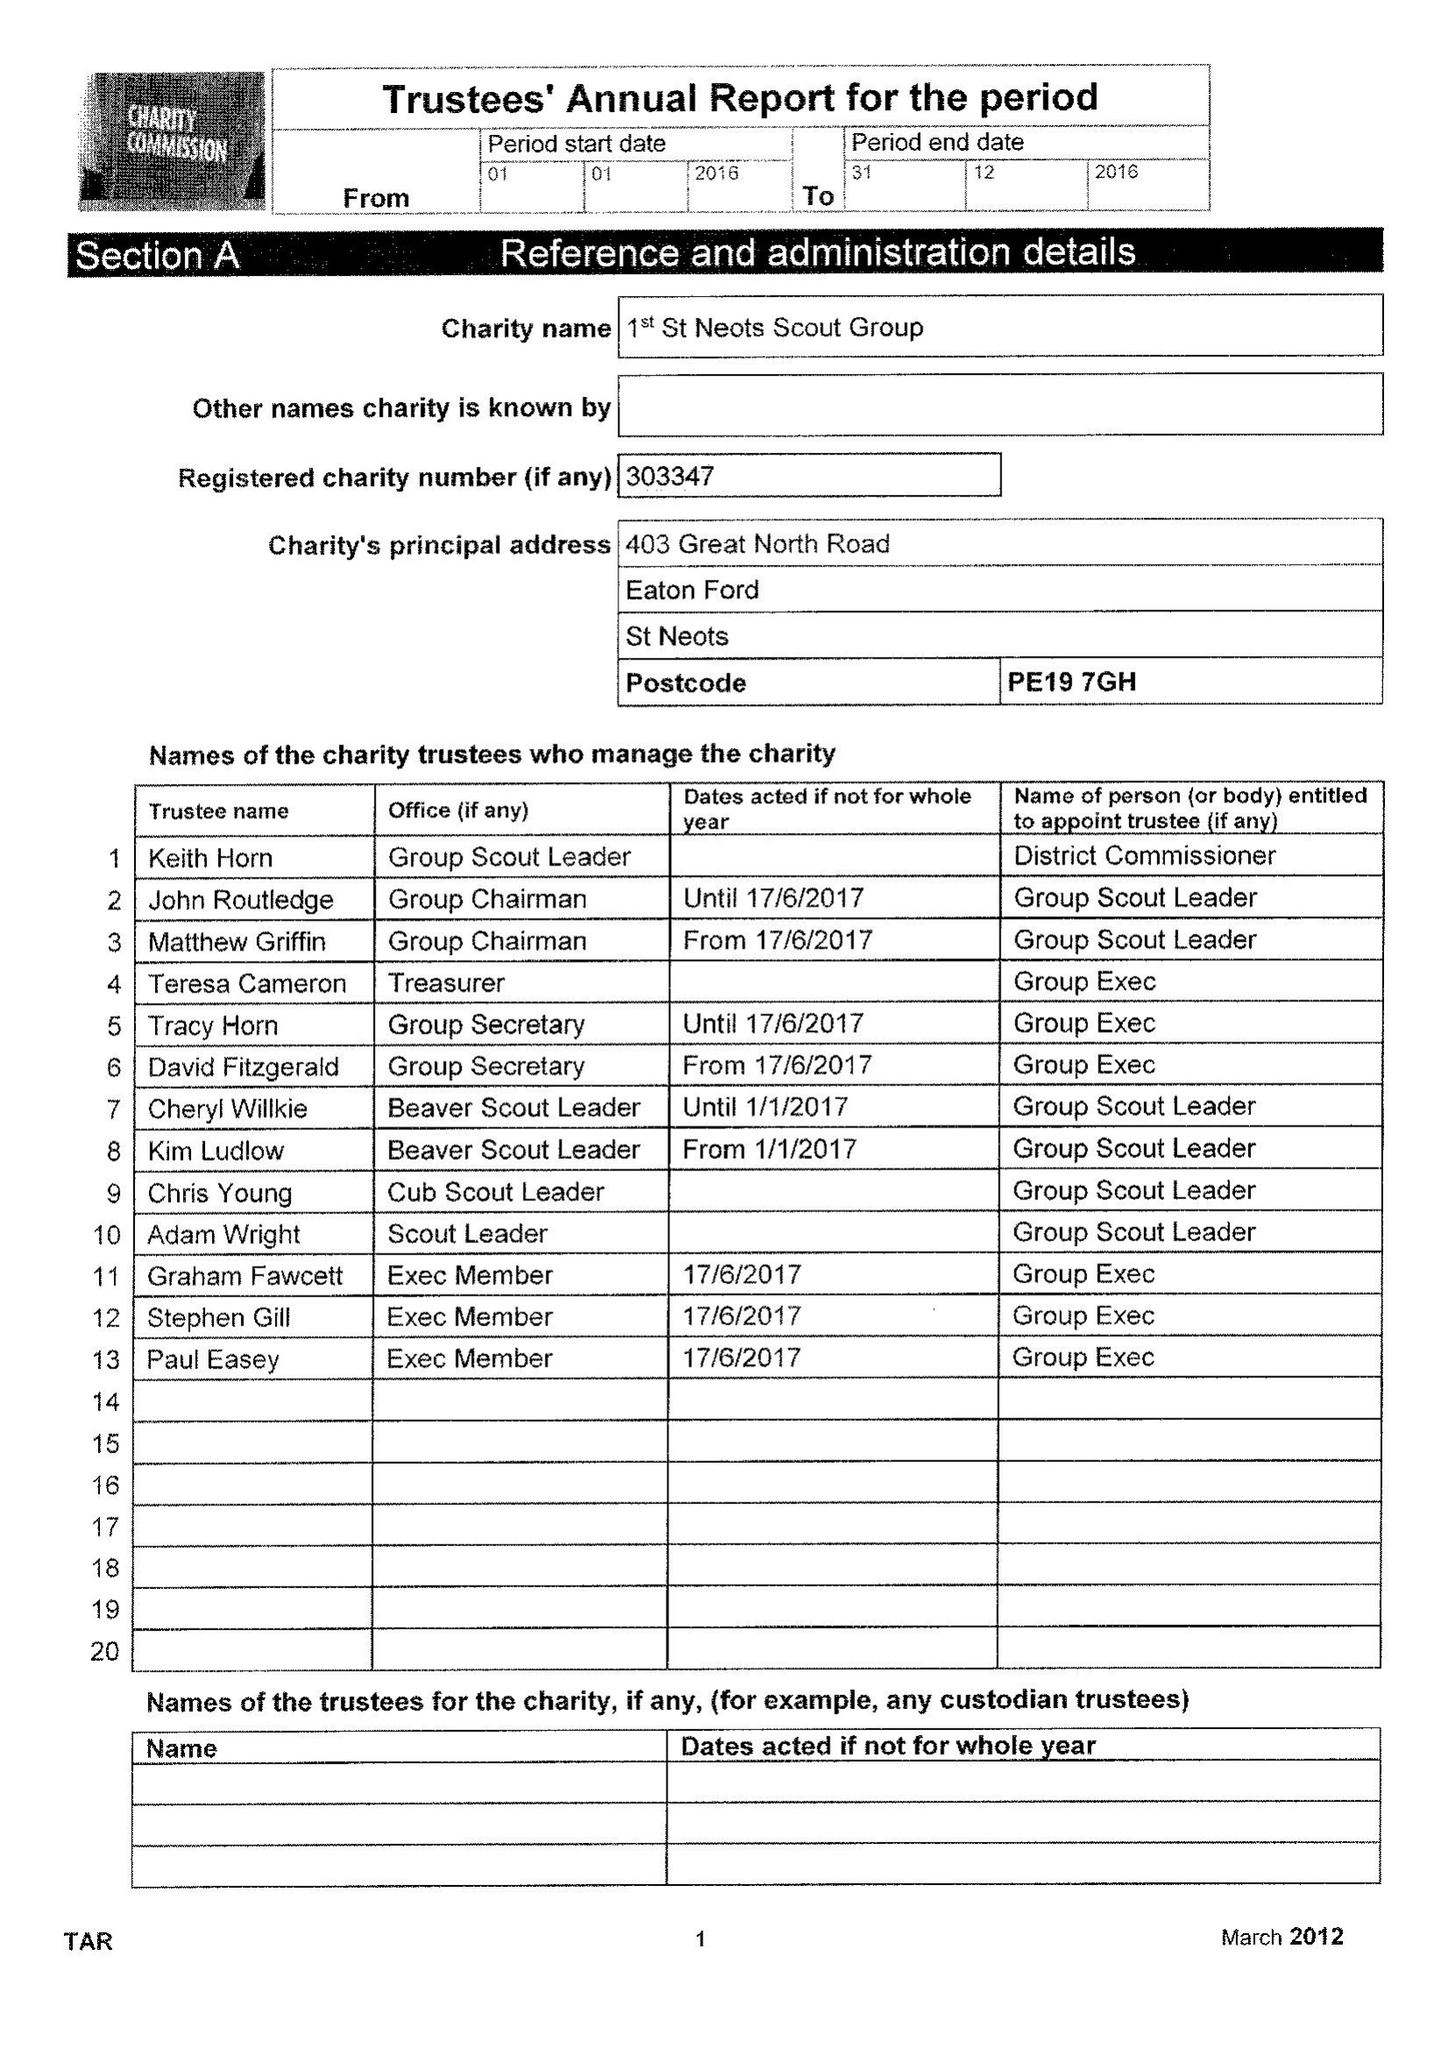What is the value for the address__street_line?
Answer the question using a single word or phrase. 403 GREAT NORTH ROAD 